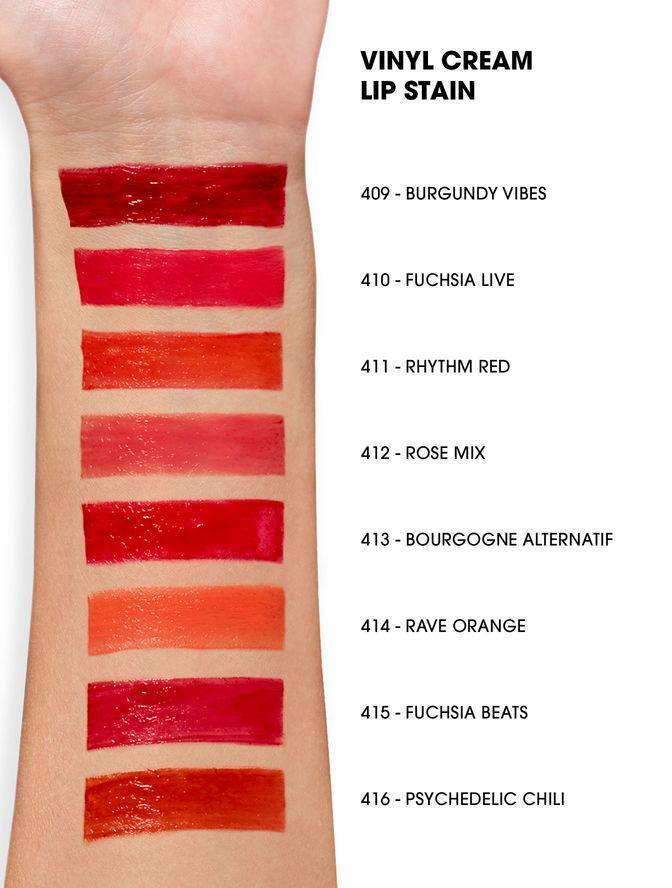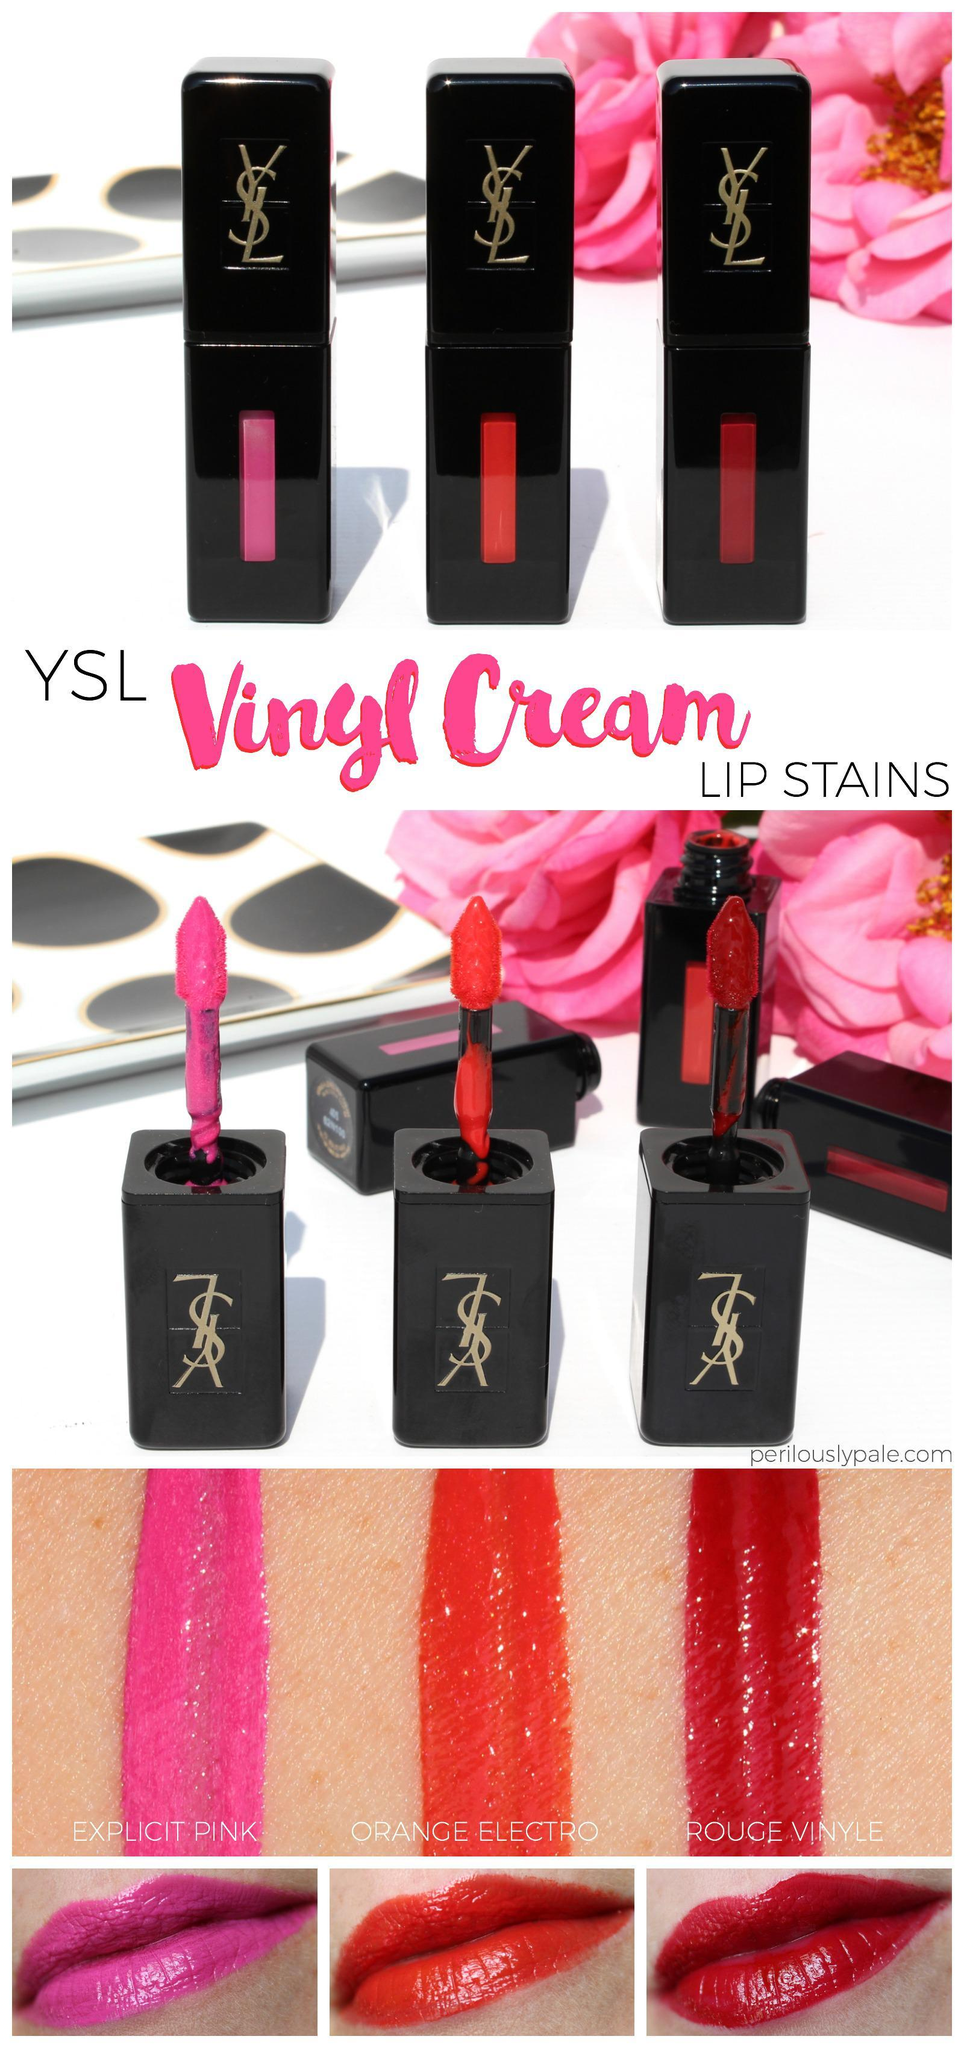The first image is the image on the left, the second image is the image on the right. Assess this claim about the two images: "A single set of lips is shown under a tube of lipstick in one of the images.". Correct or not? Answer yes or no. No. 